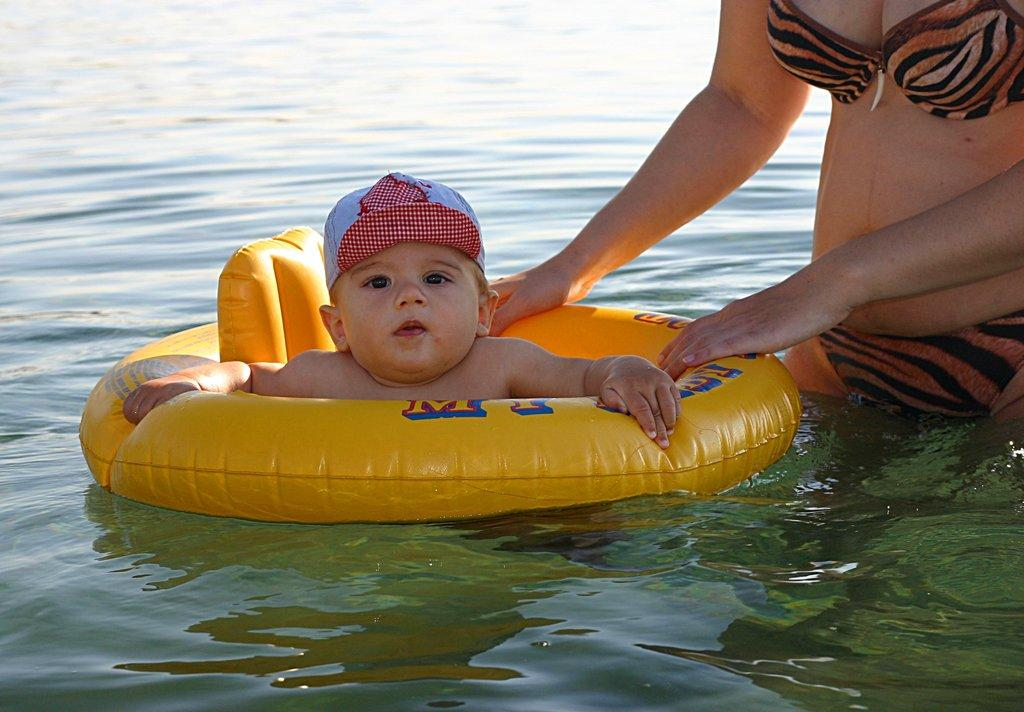What is the main subject of the image? There is a baby in the image. What is the baby holding in the image? The baby is holding a balloon. What is the baby wearing on their head? The baby is wearing a cap. Where is the baby located in the image? The baby is on the water. Who else is present in the image? There is a woman on the right side of the image. What type of sofa can be seen in the image? There is no sofa present in the image. How many casts are visible on the baby's arm in the image? There are no casts visible on the baby's arm in the image. 